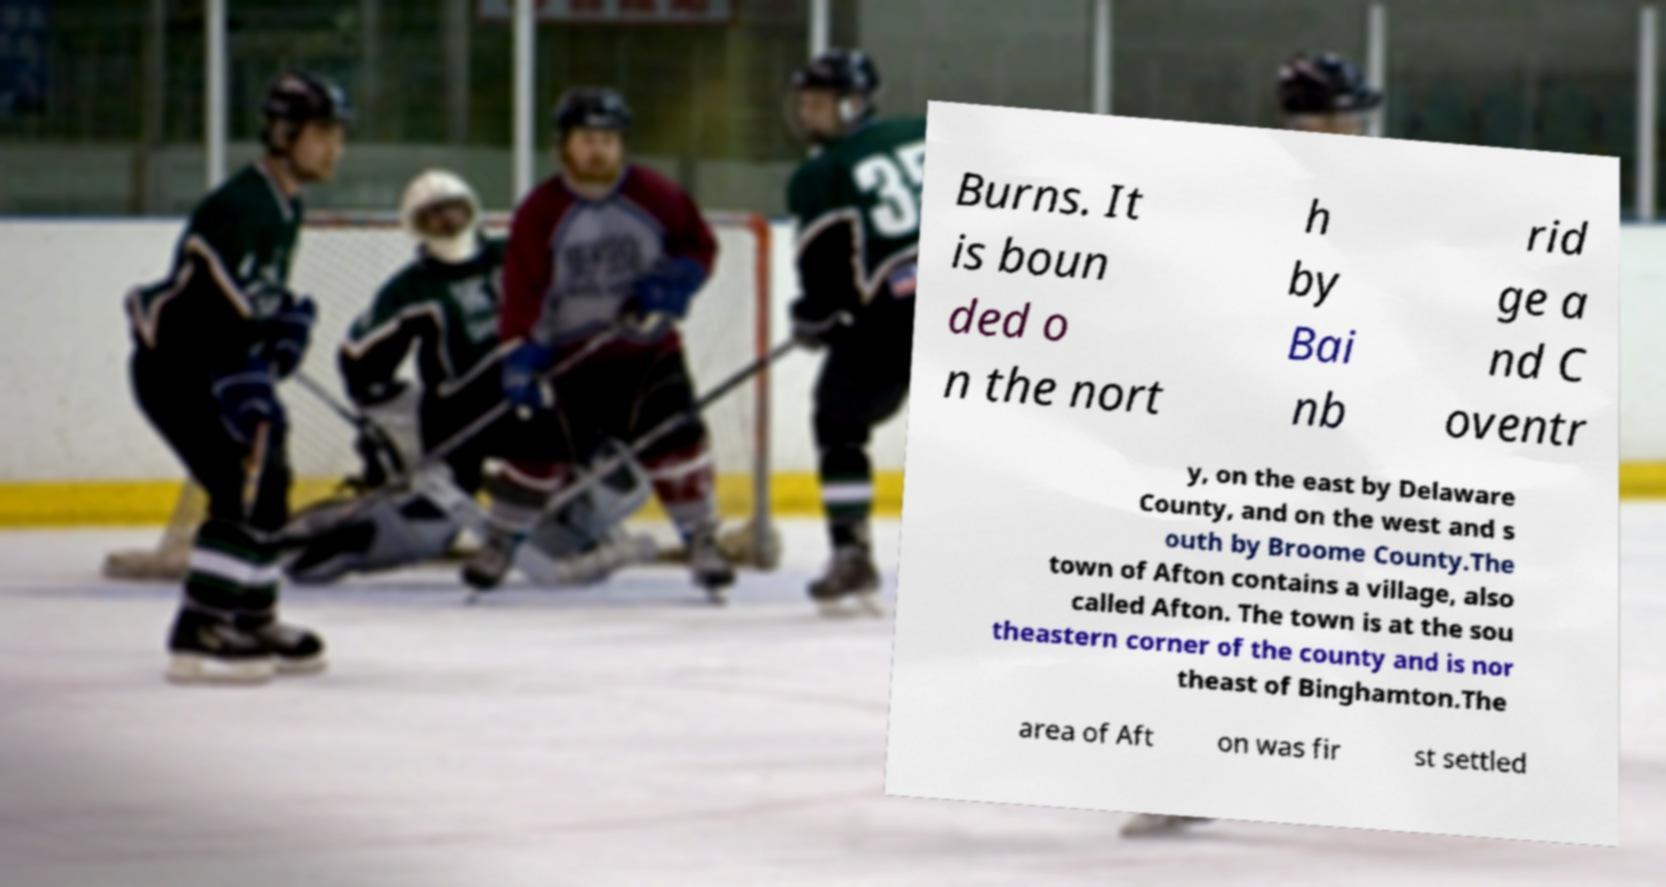Could you assist in decoding the text presented in this image and type it out clearly? Burns. It is boun ded o n the nort h by Bai nb rid ge a nd C oventr y, on the east by Delaware County, and on the west and s outh by Broome County.The town of Afton contains a village, also called Afton. The town is at the sou theastern corner of the county and is nor theast of Binghamton.The area of Aft on was fir st settled 